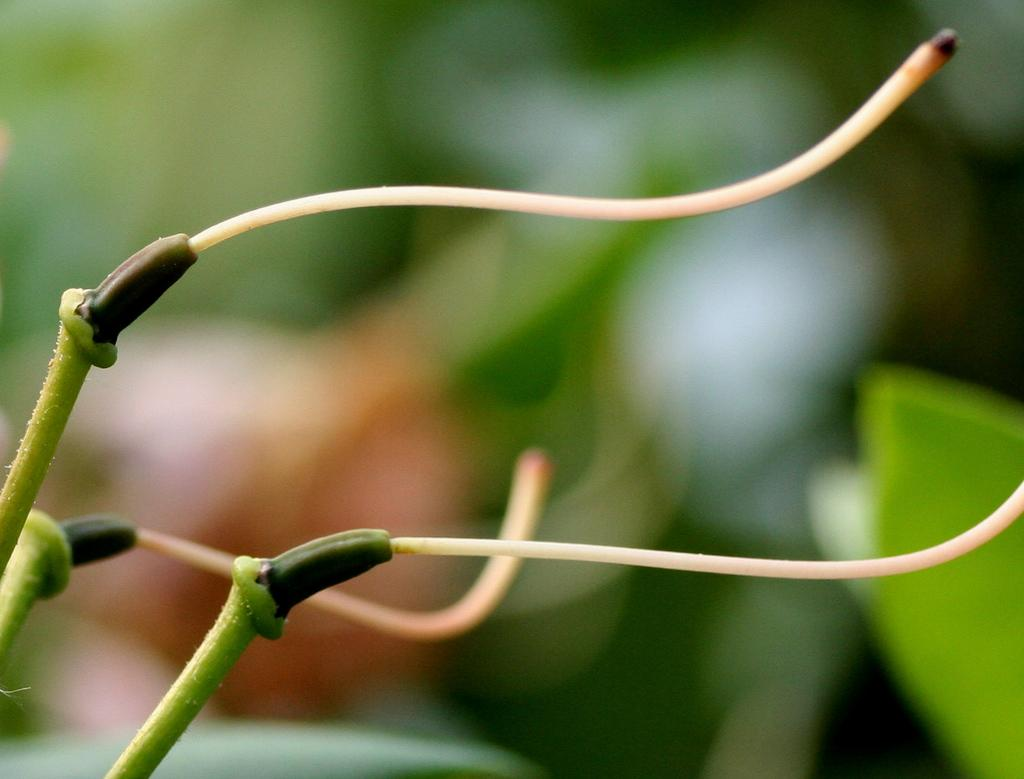What is the main subject in the center of the image? There are plants in the center of the image. What is the profit margin of the bike in the image? There is no bike present in the image, so it is not possible to determine the profit margin. 